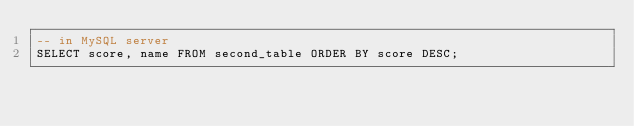Convert code to text. <code><loc_0><loc_0><loc_500><loc_500><_SQL_>-- in MySQL server
SELECT score, name FROM second_table ORDER BY score DESC;
</code> 